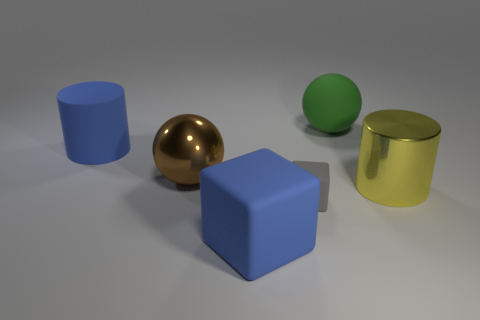Add 1 yellow matte things. How many objects exist? 7 Subtract all spheres. How many objects are left? 4 Subtract all brown things. Subtract all big brown metallic spheres. How many objects are left? 4 Add 1 matte balls. How many matte balls are left? 2 Add 1 big yellow cylinders. How many big yellow cylinders exist? 2 Subtract 0 red cubes. How many objects are left? 6 